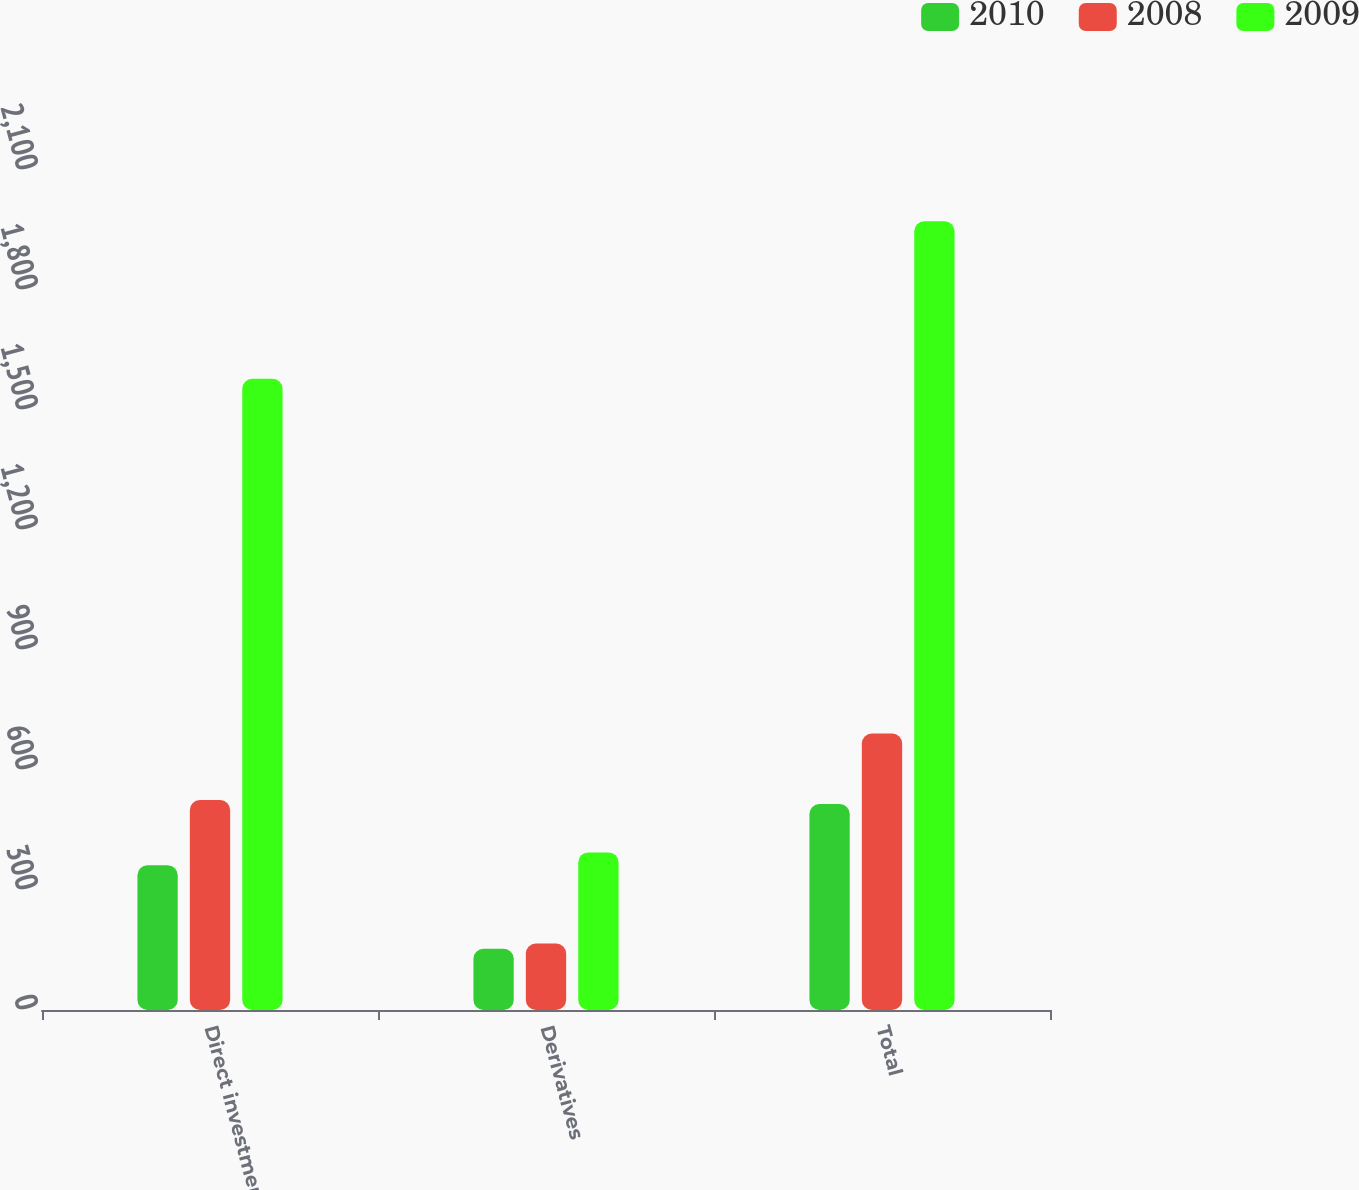Convert chart to OTSL. <chart><loc_0><loc_0><loc_500><loc_500><stacked_bar_chart><ecel><fcel>Direct investments<fcel>Derivatives<fcel>Total<nl><fcel>2010<fcel>362<fcel>153<fcel>515<nl><fcel>2008<fcel>525<fcel>166<fcel>691<nl><fcel>2009<fcel>1578<fcel>394<fcel>1972<nl></chart> 